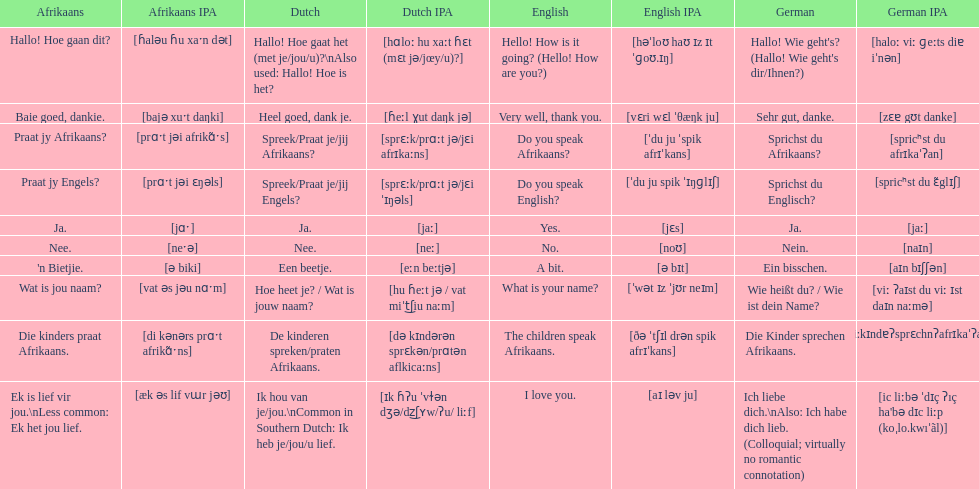How do you say 'i love you' in afrikaans? Ek is lief vir jou. 